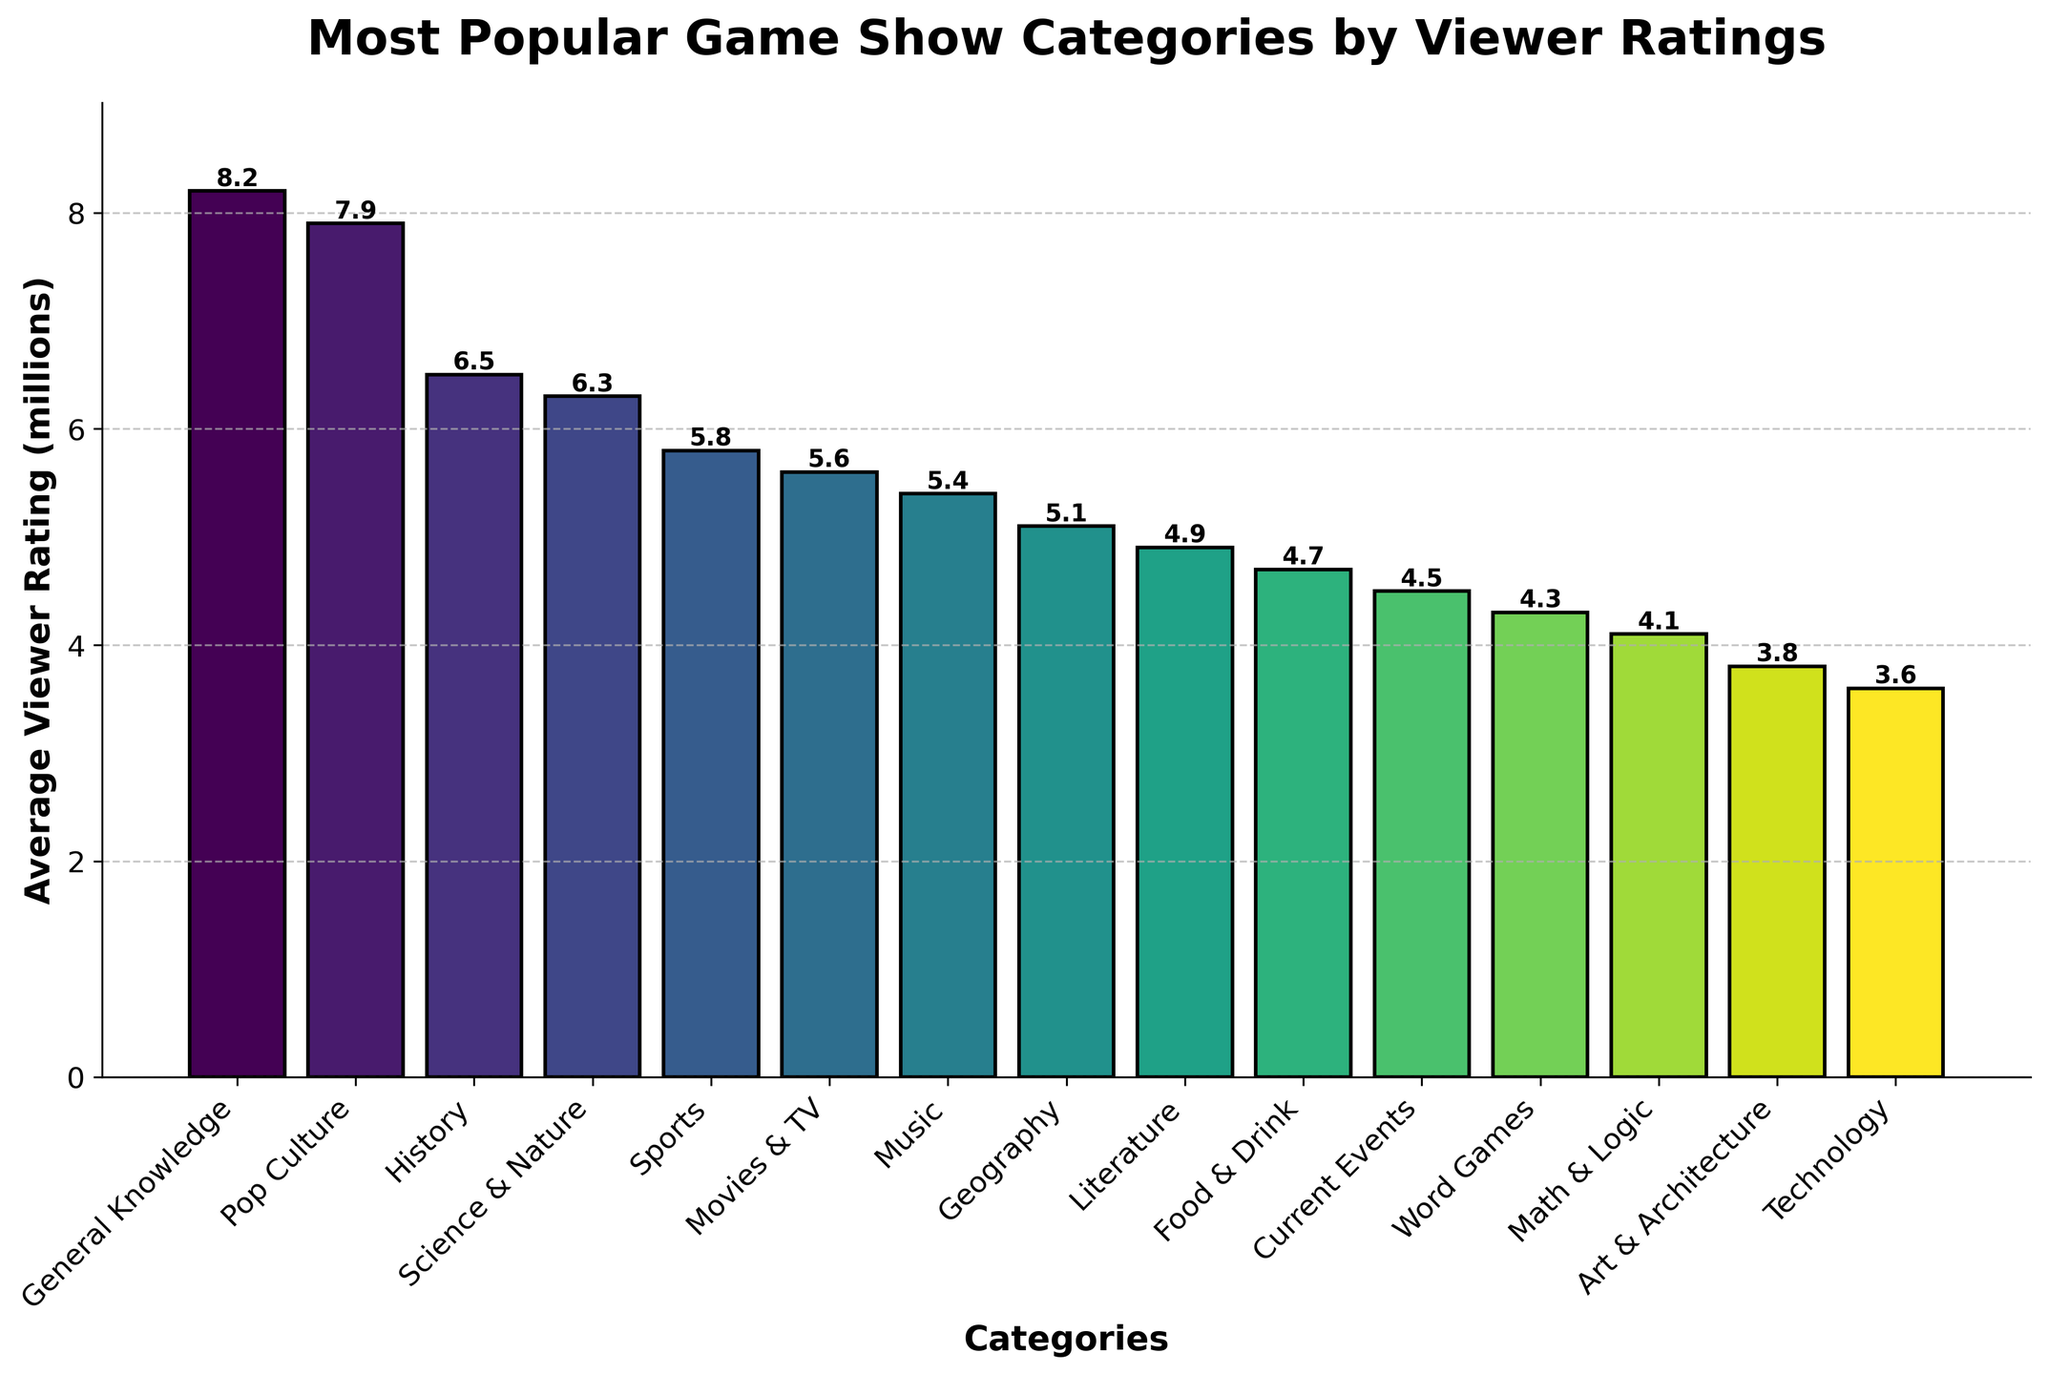What's the most popular game show category by viewer ratings? The highest bar on the chart represents the category with the greatest viewer rating. "General Knowledge" has the tallest bar, indicating it is the most popular category.
Answer: General Knowledge How many categories have an average viewer rating above 6 million? Identify all the bars that reach above the 6 million mark on the vertical axis. They are "General Knowledge", "Pop Culture", "History", and "Science & Nature". Count these categories.
Answer: 4 What's the difference in viewer ratings between the highest and the lowest category? The highest rating is for "General Knowledge" at 8.2 million and the lowest for "Technology" at 3.6 million. The difference is calculated as 8.2 - 3.6.
Answer: 4.6 million Which category has a viewer rating closest to the average rating of all categories? First, find the average rating by adding all ratings and dividing by the number of categories. Then, identify the bar with the value closest to this average.
Answer: History Are there more categories with viewer ratings above or below 5 million? Count the number of categories with ratings above 5 million and those below it by checking each bar's height against the 5 million mark. Compare these counts.
Answer: Below What categories have viewer ratings within 0.5 million of each other? Examine the heights of all the bars and spot those where the heights are within 0.5 million viewer ratings of each other. For example, "Music" at 5.4 million and "Geography" at 5.1 million.
Answer: Pop Culture & History, Science & Nature & Sports, Music & Geography Which categories are rated higher than "Mathematics & Logic" but lower than "Science & Nature"? Find bars between the heights of "Mathematics & Logic" (4.1 million) and "Science & Nature" (6.3 million). Identify the categories represented by these bars.
Answer: Geography, Literature, Food & Drink, Current Events, Word Games Which three categories have the lowest viewer ratings? Look for the three shortest bars on the chart and identify the categories they represent.
Answer: Art & Architecture, Technology, Math & Logic By how much does "Pop Culture" exceed "Movies & TV" in viewer ratings? Find the viewer ratings for "Pop Culture" (7.9 million) and "Movies & TV" (5.6 million). Subtract the rating of "Movies & TV" from that of "Pop Culture".
Answer: 2.3 million Which category stands out visually due to its bar color in comparison to surrounding bars? Observe the bar colors and identify if any category has a distinctly different color or shade from its adjacent categories' bars.
Answer: This is visually subjective but often "General Knowledge" stands out due to its tall height and positioning 